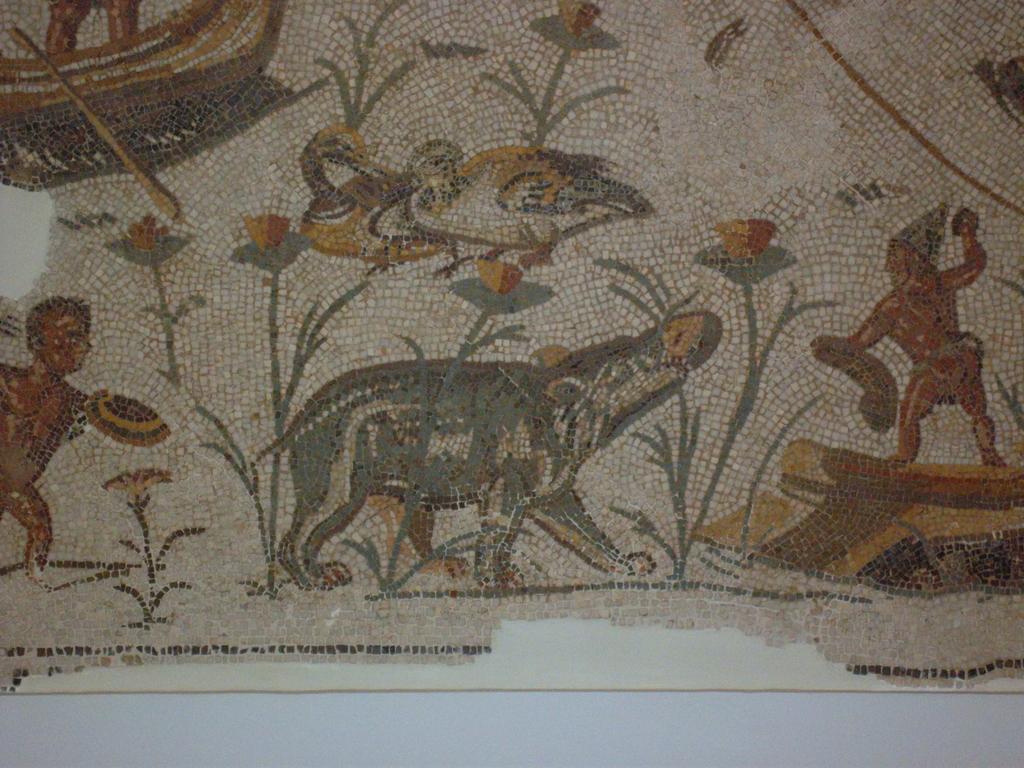How would you summarize this image in a sentence or two? In this image there is a poster with an art of human and animals on the wall. 